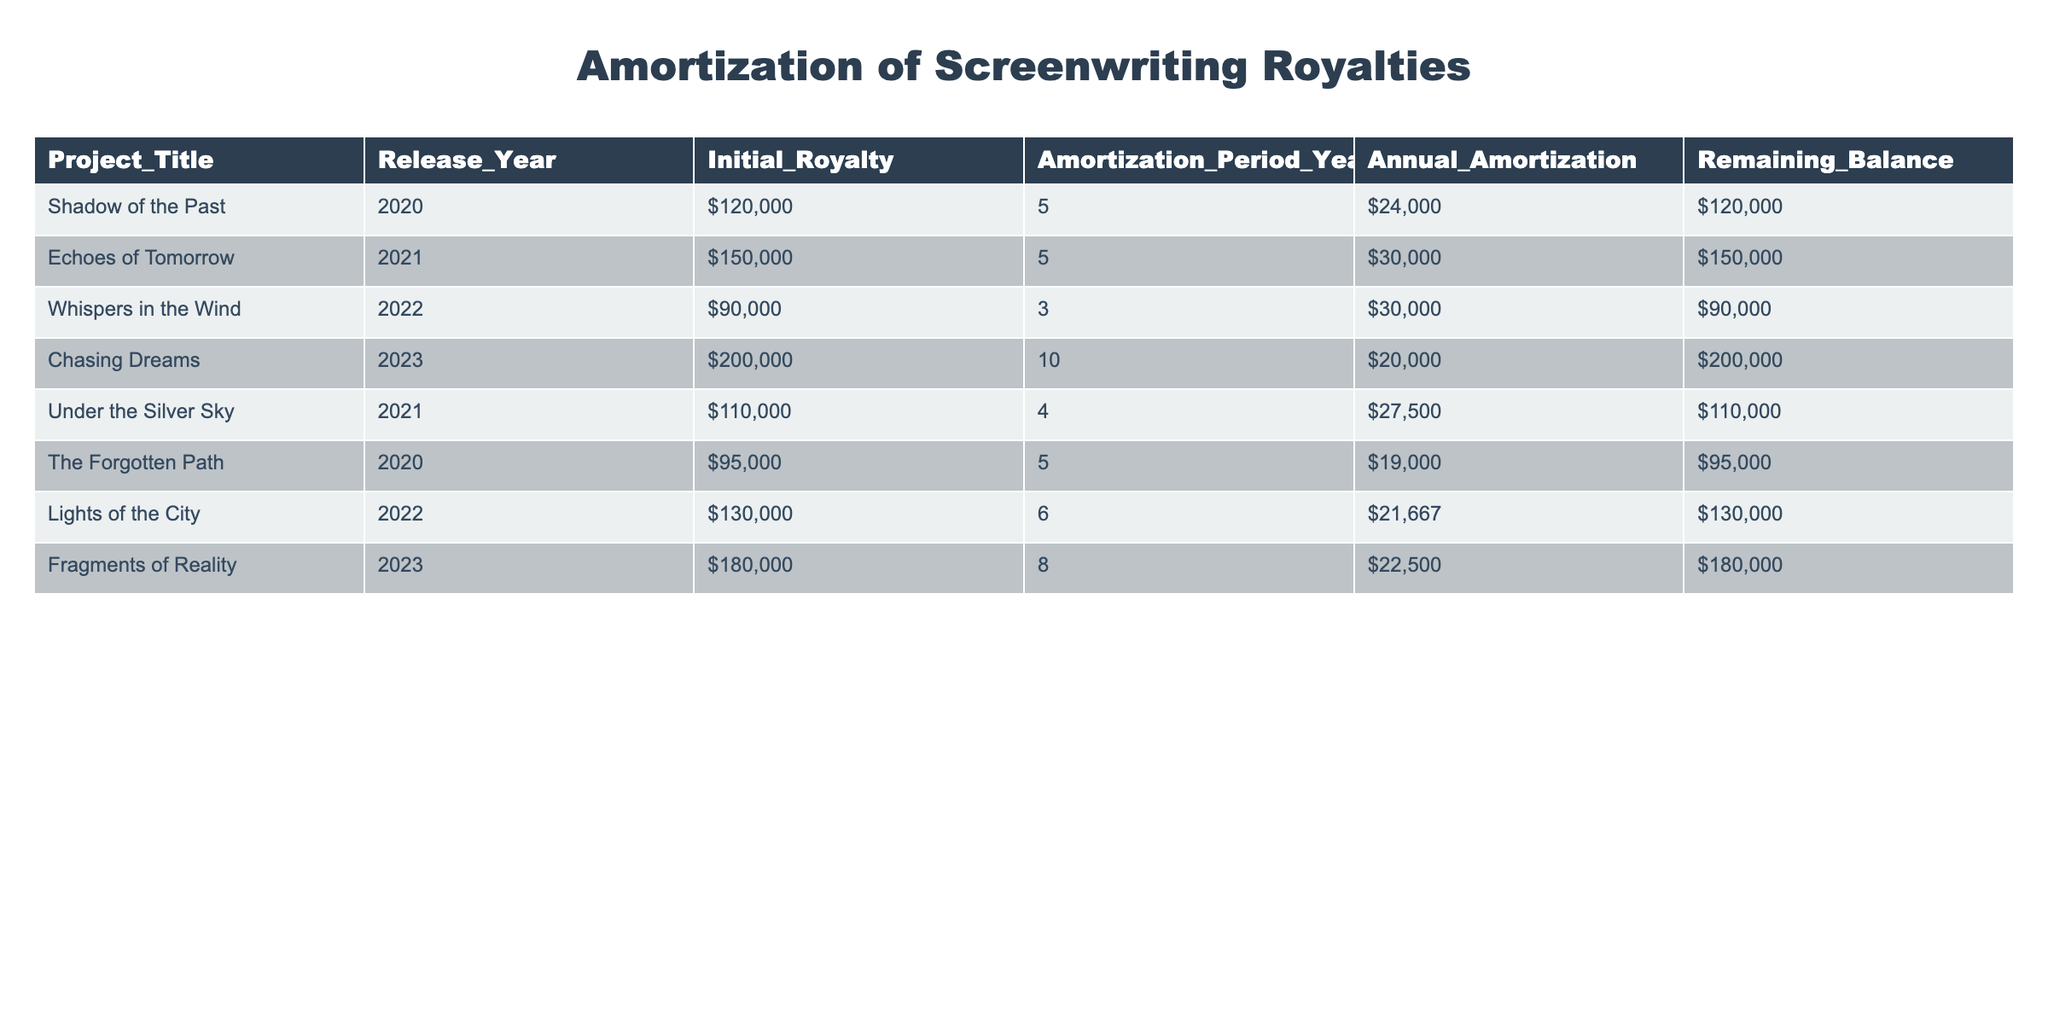Which project has the highest initial royalty? Looking at the "Initial_Royalty" column, "Chasing Dreams" has the highest initial royalty listed at $200,000.
Answer: Chasing Dreams What is the annual amortization for "Whispers in the Wind"? Referring to the "Annual_Amortization" column for "Whispers in the Wind", the value is $30,000.
Answer: $30,000 How many years is the amortization period for "Echoes of Tomorrow"? The table indicates that "Echoes of Tomorrow" has an amortization period of 5 years.
Answer: 5 years Is the remaining balance for "Lights of the City" greater than $100,000? The remaining balance for "Lights of the City" is $130,000, which is greater than $100,000.
Answer: Yes What is the total initial royalty for projects released in 2021? The projects released in 2021 are "Echoes of Tomorrow" ($150,000) and "Under the Silver Sky" ($110,000). Adding them gives $150,000 + $110,000 = $260,000 for a total initial royalty.
Answer: $260,000 Which project has the shortest amortization period, and what is that period? Checking the "Amortization_Period_Years", "Whispers in the Wind" has the shortest period of 3 years.
Answer: 3 years How much is the combined annual amortization for projects released in the year 2020? The projects from 2020 are "Shadow of the Past" ($24,000) and "The Forgotten Path" ($19,000). The sum is $24,000 + $19,000 = $43,000.
Answer: $43,000 Does "Fragements of Reality" have a remaining balance less than $180,000? "Fragments of Reality" has a remaining balance of $180,000, which is not less than $180,000.
Answer: No What is the average annual amortization across all projects? To find the average, first sum the annual amortizations: $24,000 + $30,000 + $30,000 + $20,000 + $27,500 + $19,000 + $21,667 + $22,500 = $224,667. There are 8 projects, so the average is $224,667 / 8 = $28,083.375, rounding to $28,083.
Answer: $28,083 